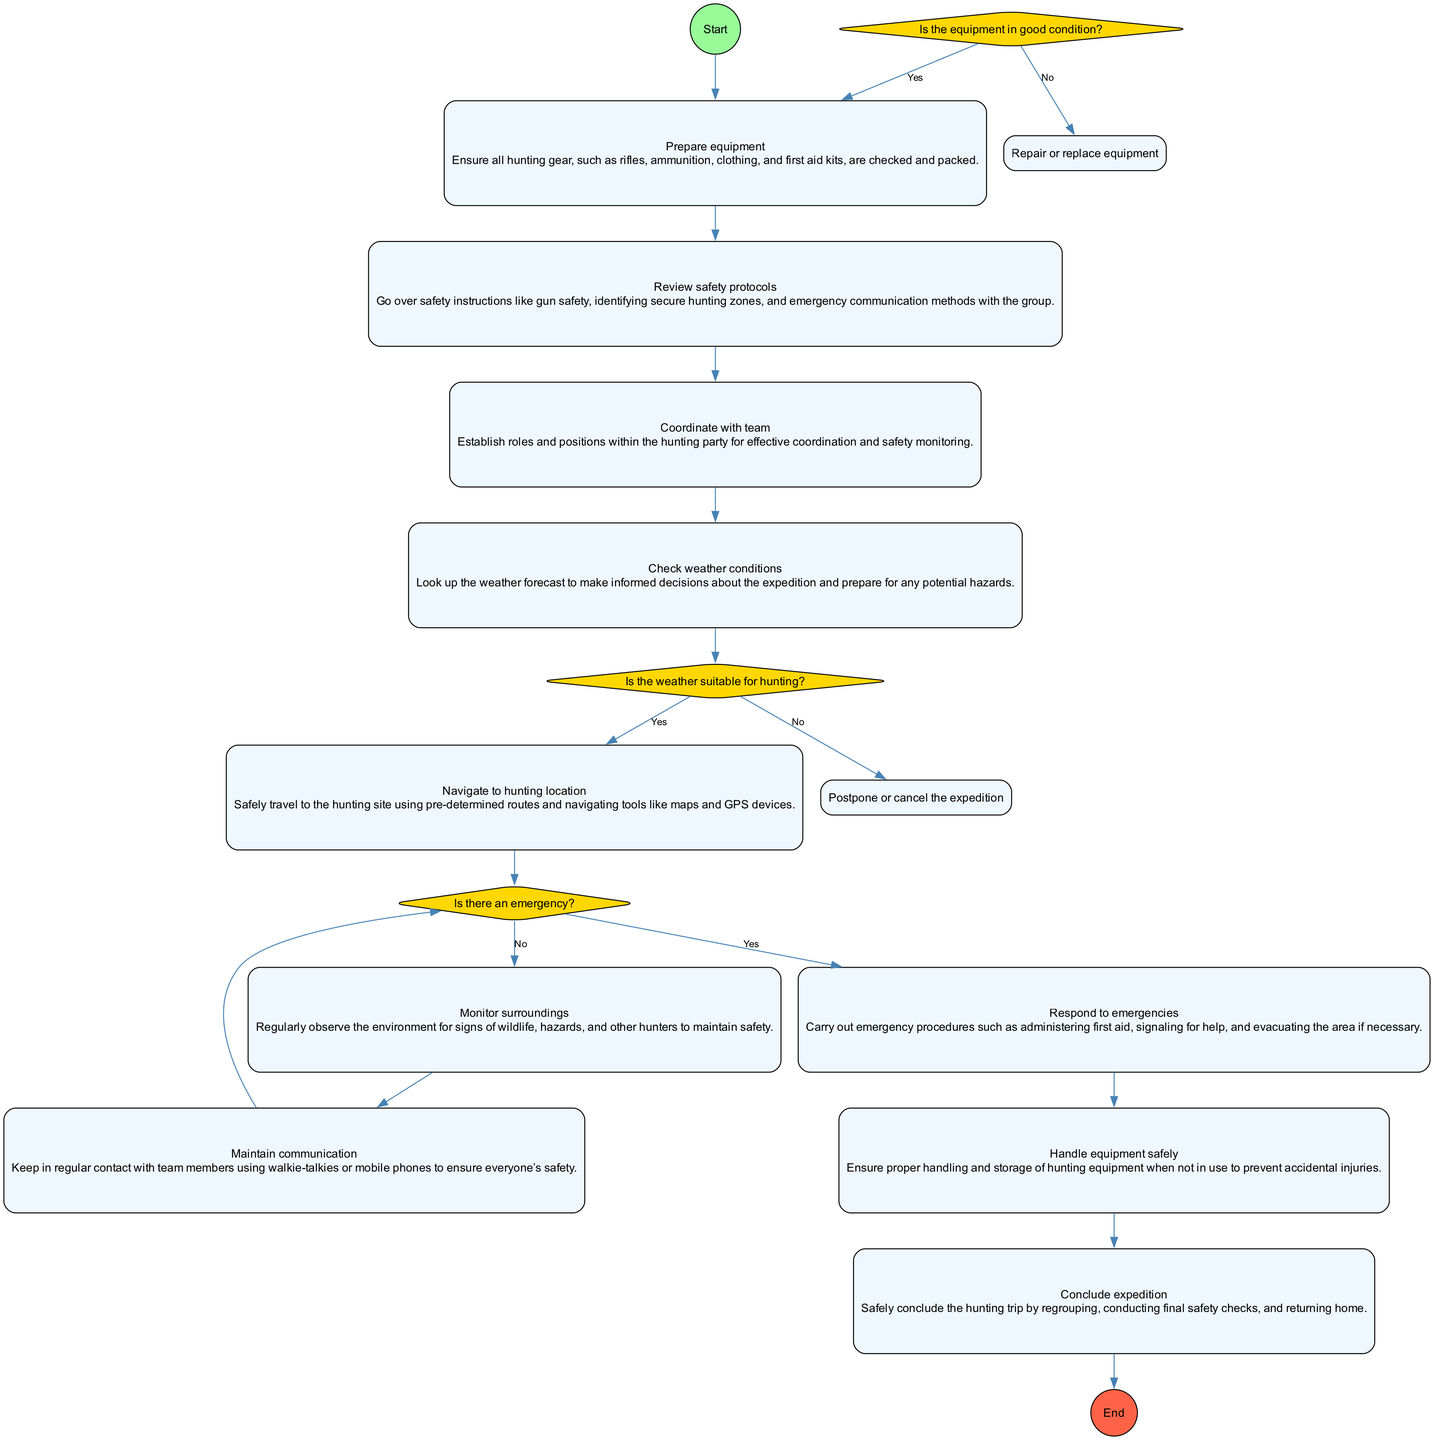What is the first action in the diagram? The diagram starts with the node labeled "Prepare equipment," indicating that this is the initial action to take before any other steps.
Answer: Prepare equipment What decision follows after "Prepare equipment"? After "Prepare equipment," the next step involves checking the condition of the equipment, which leads to the decision node "Is the equipment in good condition?".
Answer: Is the equipment in good condition? How many actions are in the diagram? The diagram contains a total of 10 distinct action nodes, representing various steps to ensure safety during the hunting expedition.
Answer: 10 What happens if the weather is not suitable for hunting? According to the diagram, if the weather is not suitable, the flow leads to the action "Postpone or cancel the expedition," indicating that the expedition will not proceed in adverse weather conditions.
Answer: Postpone or cancel the expedition What is the last action in the activity diagram? The final action in the diagram is "Conclude expedition," which signifies the conclusion of the entire hunting activity after all procedures have been followed.
Answer: Conclude expedition What is the relationship between "Respond to emergencies" and "Monitor surroundings"? The diagram shows that if there is an emergency, the flow directs to "Respond to emergencies," while if there is no emergency, the flow goes to "Monitor surroundings," reflecting a decision-making process based on whether an emergency exists.
Answer: Decision point What actions follow after "Check weather conditions"? Upon checking the weather conditions, if the weather is suitable, the next action is to "Navigate to hunting location." If not suitable, the expedition is postponed or canceled. This shows a conditional flow from one action to another based on the weather's status.
Answer: Navigate to hunting location, Postpone or cancel the expedition Which action involves the handling of hunting equipment? "Handle equipment safely" is the specific action mentioned in the diagram that focuses on the proper handling and storage of hunting gear to avoid accidental injuries.
Answer: Handle equipment safely How many decisions are present in the diagram? The diagram contains 3 decision nodes that guide the workflow based on specific conditions regarding equipment, weather, and emergencies.
Answer: 3 